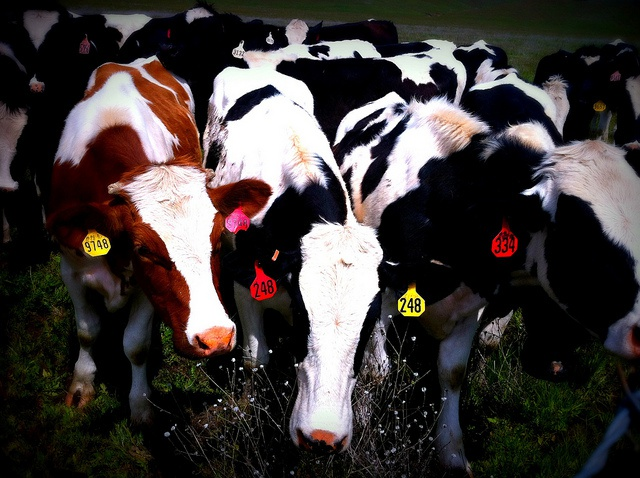Describe the objects in this image and their specific colors. I can see cow in black, white, darkgray, and gray tones, cow in black, white, and maroon tones, cow in black, white, darkgray, and gray tones, cow in black, gray, and maroon tones, and cow in black, lightgray, darkgray, and gray tones in this image. 